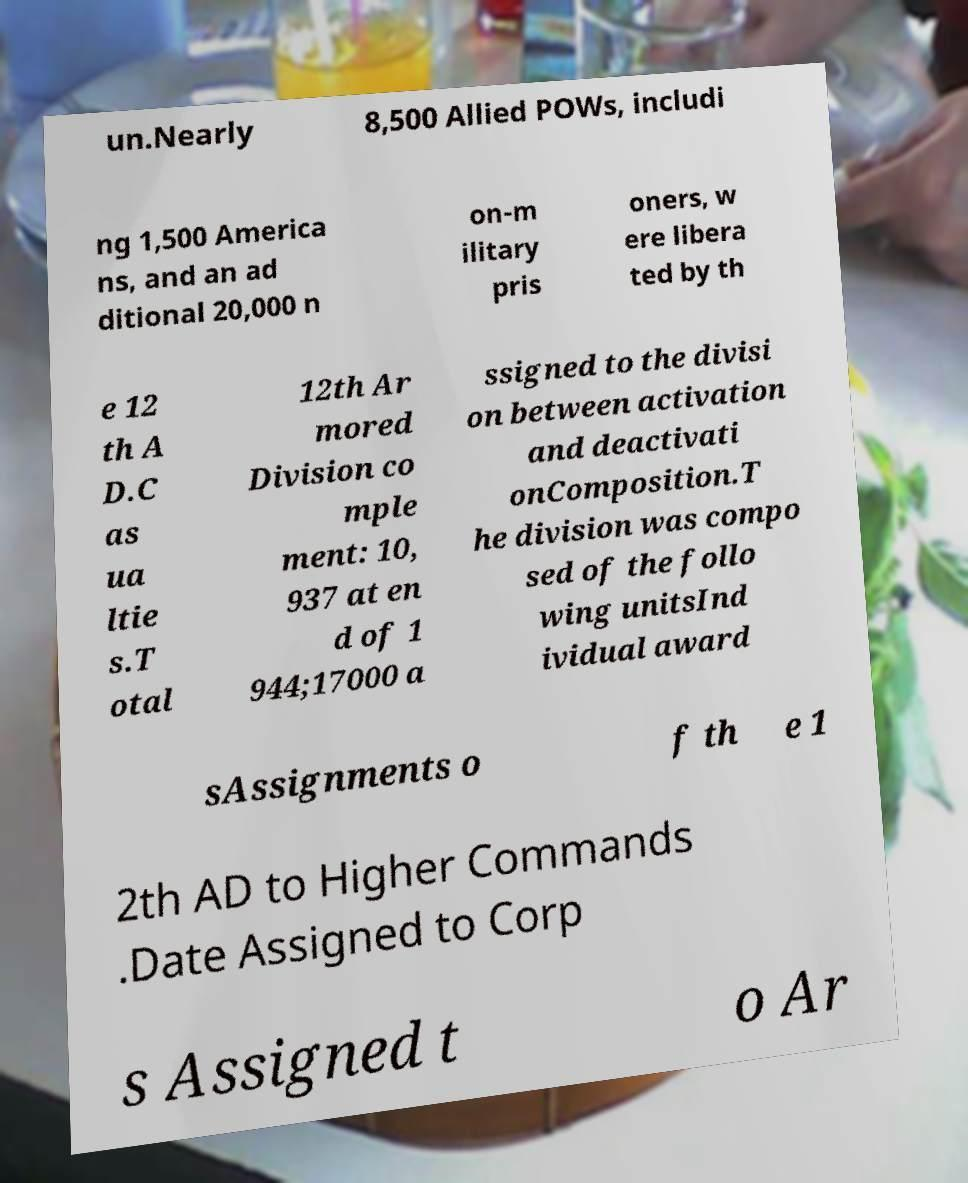Can you accurately transcribe the text from the provided image for me? un.Nearly 8,500 Allied POWs, includi ng 1,500 America ns, and an ad ditional 20,000 n on-m ilitary pris oners, w ere libera ted by th e 12 th A D.C as ua ltie s.T otal 12th Ar mored Division co mple ment: 10, 937 at en d of 1 944;17000 a ssigned to the divisi on between activation and deactivati onComposition.T he division was compo sed of the follo wing unitsInd ividual award sAssignments o f th e 1 2th AD to Higher Commands .Date Assigned to Corp s Assigned t o Ar 